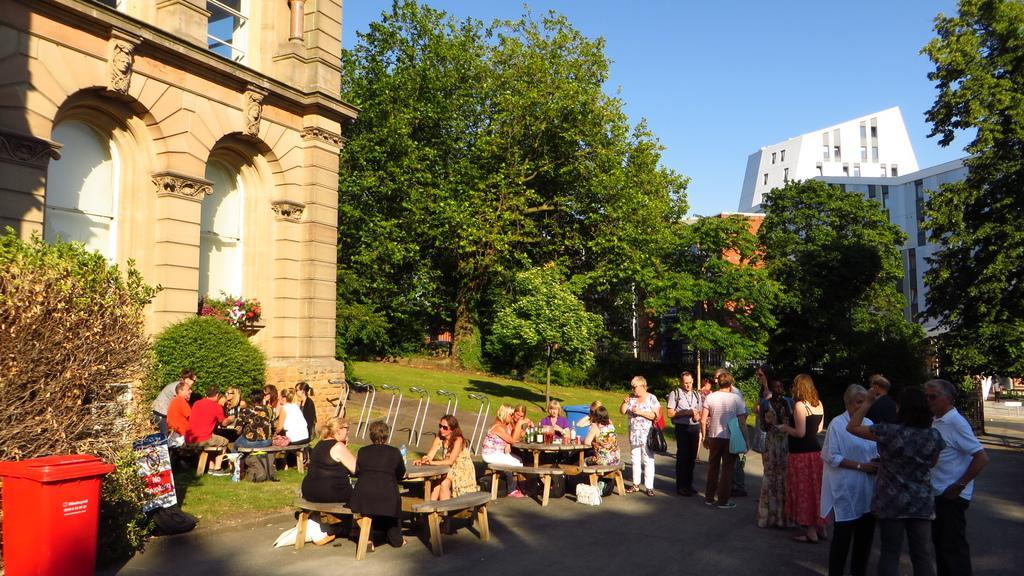Could you give a brief overview of what you see in this image? In the center of the image, we can see tables and there are bottles on them and we can see people sitting on the chairs. In the background, there are some other people standing and we can see trees, buildings, bushes and poles. On the bottom left, we can see a bin, which is in red color. At the bottom, there is ground and at the top, there is sky. 